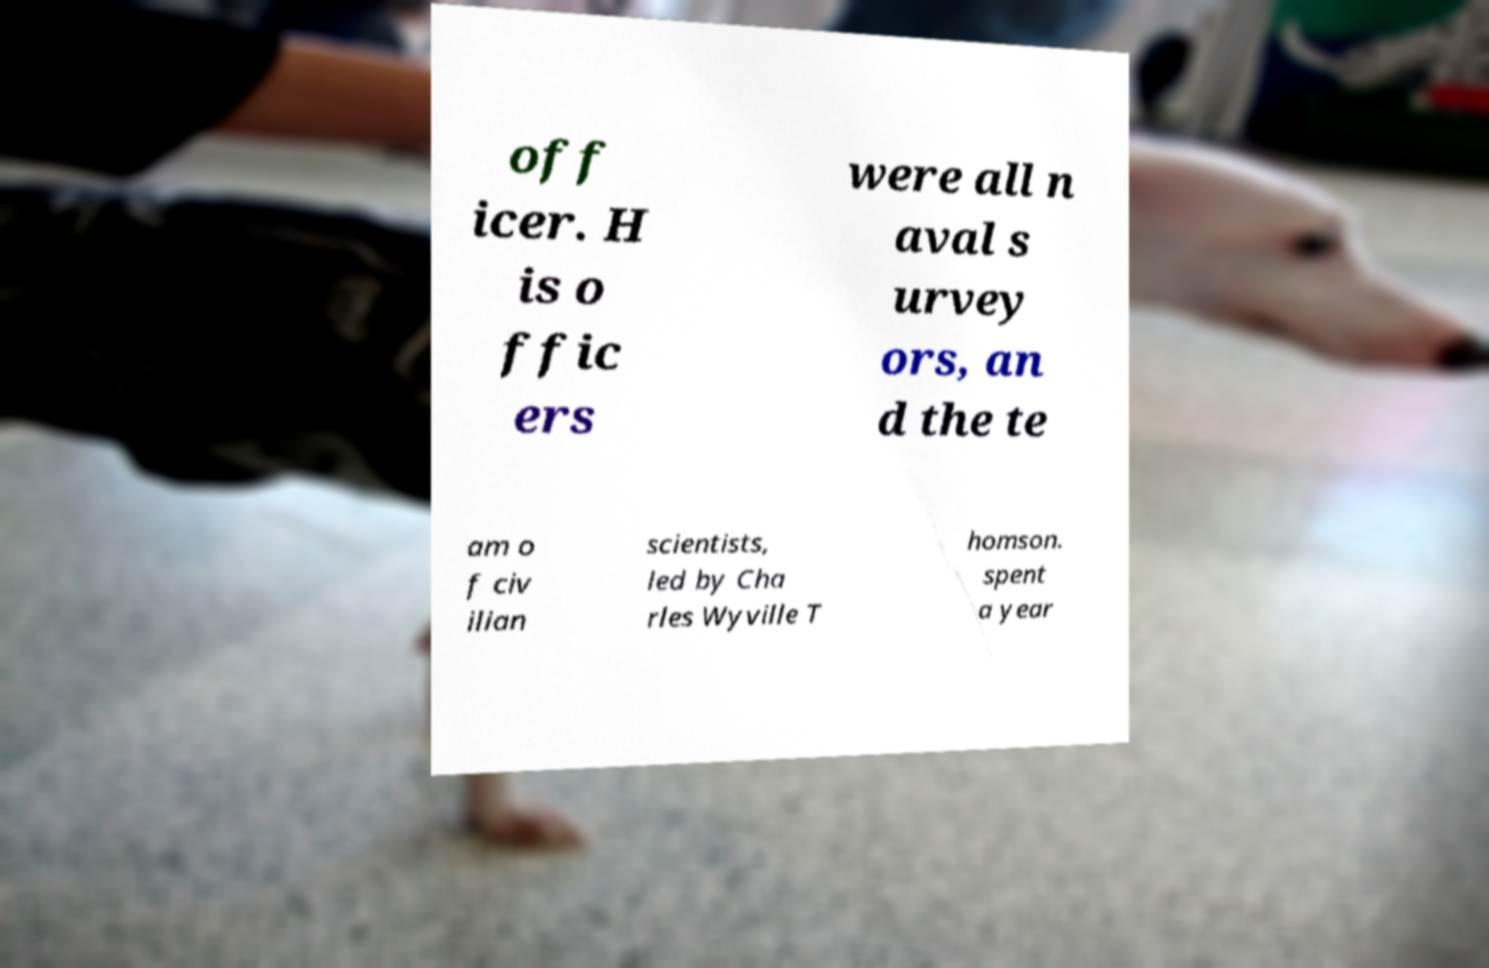What messages or text are displayed in this image? I need them in a readable, typed format. off icer. H is o ffic ers were all n aval s urvey ors, an d the te am o f civ ilian scientists, led by Cha rles Wyville T homson. spent a year 